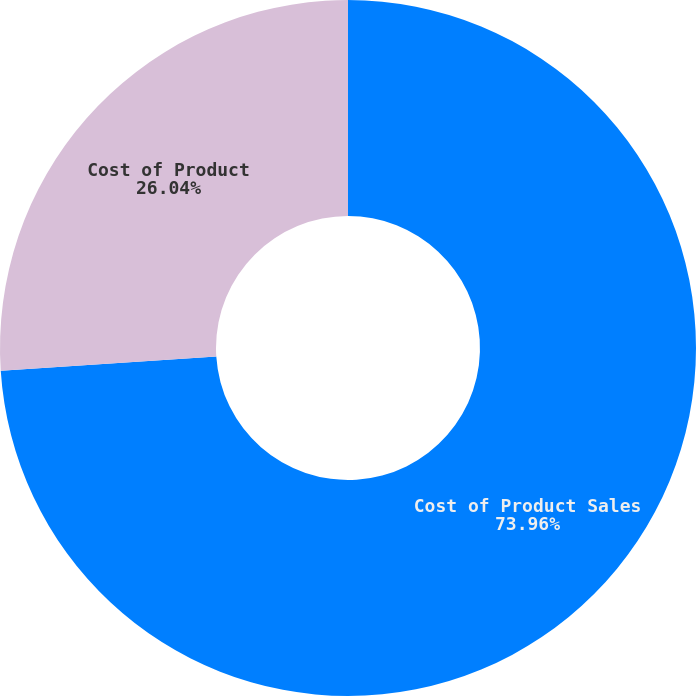Convert chart to OTSL. <chart><loc_0><loc_0><loc_500><loc_500><pie_chart><fcel>Cost of Product Sales<fcel>Cost of Product<nl><fcel>73.96%<fcel>26.04%<nl></chart> 